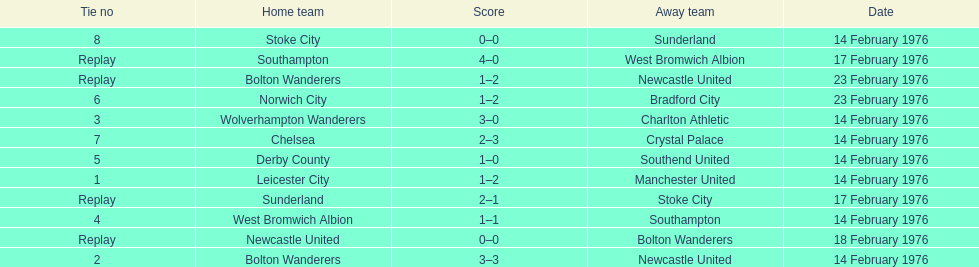Could you help me parse every detail presented in this table? {'header': ['Tie no', 'Home team', 'Score', 'Away team', 'Date'], 'rows': [['8', 'Stoke City', '0–0', 'Sunderland', '14 February 1976'], ['Replay', 'Southampton', '4–0', 'West Bromwich Albion', '17 February 1976'], ['Replay', 'Bolton Wanderers', '1–2', 'Newcastle United', '23 February 1976'], ['6', 'Norwich City', '1–2', 'Bradford City', '23 February 1976'], ['3', 'Wolverhampton Wanderers', '3–0', 'Charlton Athletic', '14 February 1976'], ['7', 'Chelsea', '2–3', 'Crystal Palace', '14 February 1976'], ['5', 'Derby County', '1–0', 'Southend United', '14 February 1976'], ['1', 'Leicester City', '1–2', 'Manchester United', '14 February 1976'], ['Replay', 'Sunderland', '2–1', 'Stoke City', '17 February 1976'], ['4', 'West Bromwich Albion', '1–1', 'Southampton', '14 February 1976'], ['Replay', 'Newcastle United', '0–0', 'Bolton Wanderers', '18 February 1976'], ['2', 'Bolton Wanderers', '3–3', 'Newcastle United', '14 February 1976']]} Who had a better score, manchester united or wolverhampton wanderers? Wolverhampton Wanderers. 